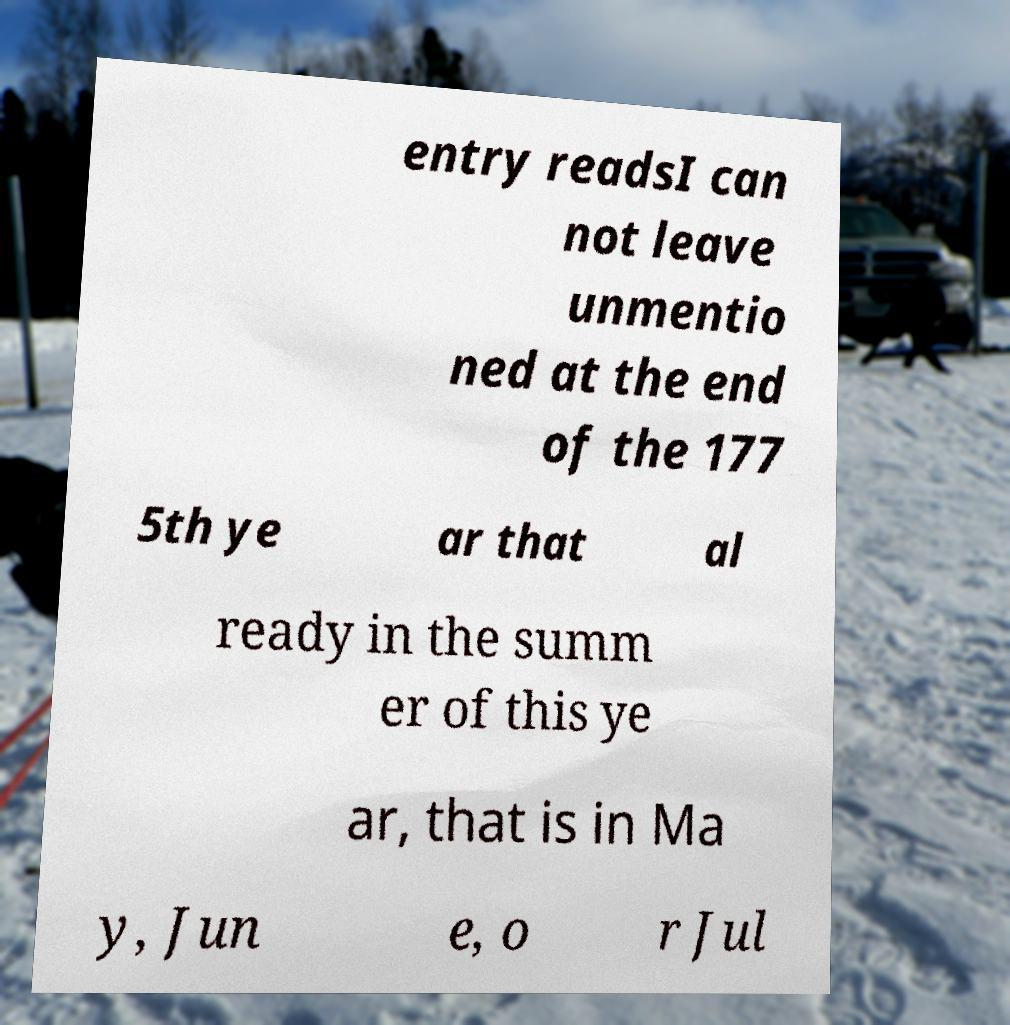Can you read and provide the text displayed in the image?This photo seems to have some interesting text. Can you extract and type it out for me? entry readsI can not leave unmentio ned at the end of the 177 5th ye ar that al ready in the summ er of this ye ar, that is in Ma y, Jun e, o r Jul 